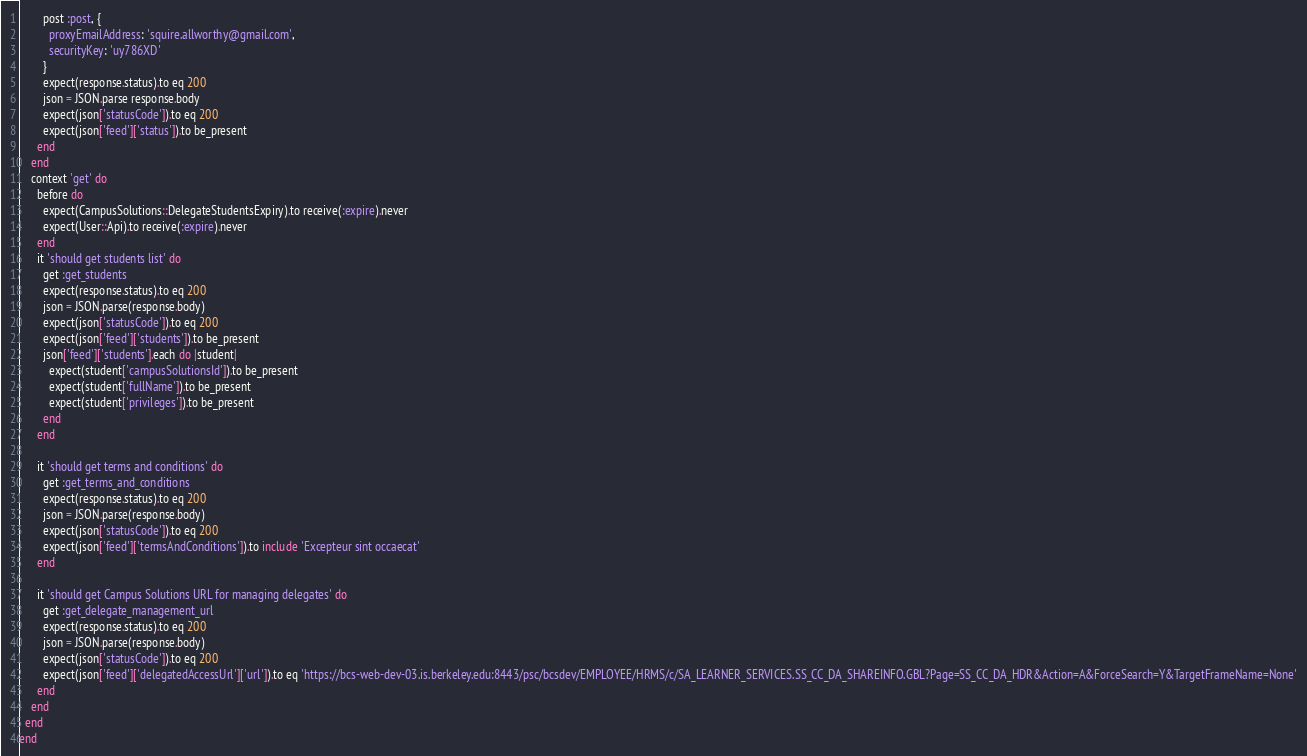Convert code to text. <code><loc_0><loc_0><loc_500><loc_500><_Ruby_>        post :post, {
          proxyEmailAddress: 'squire.allworthy@gmail.com',
          securityKey: 'uy786XD'
        }
        expect(response.status).to eq 200
        json = JSON.parse response.body
        expect(json['statusCode']).to eq 200
        expect(json['feed']['status']).to be_present
      end
    end
    context 'get' do
      before do
        expect(CampusSolutions::DelegateStudentsExpiry).to receive(:expire).never
        expect(User::Api).to receive(:expire).never
      end
      it 'should get students list' do
        get :get_students
        expect(response.status).to eq 200
        json = JSON.parse(response.body)
        expect(json['statusCode']).to eq 200
        expect(json['feed']['students']).to be_present
        json['feed']['students'].each do |student|
          expect(student['campusSolutionsId']).to be_present
          expect(student['fullName']).to be_present
          expect(student['privileges']).to be_present
        end
      end

      it 'should get terms and conditions' do
        get :get_terms_and_conditions
        expect(response.status).to eq 200
        json = JSON.parse(response.body)
        expect(json['statusCode']).to eq 200
        expect(json['feed']['termsAndConditions']).to include 'Excepteur sint occaecat'
      end

      it 'should get Campus Solutions URL for managing delegates' do
        get :get_delegate_management_url
        expect(response.status).to eq 200
        json = JSON.parse(response.body)
        expect(json['statusCode']).to eq 200
        expect(json['feed']['delegatedAccessUrl']['url']).to eq 'https://bcs-web-dev-03.is.berkeley.edu:8443/psc/bcsdev/EMPLOYEE/HRMS/c/SA_LEARNER_SERVICES.SS_CC_DA_SHAREINFO.GBL?Page=SS_CC_DA_HDR&Action=A&ForceSearch=Y&TargetFrameName=None'
      end
    end
  end
end
</code> 